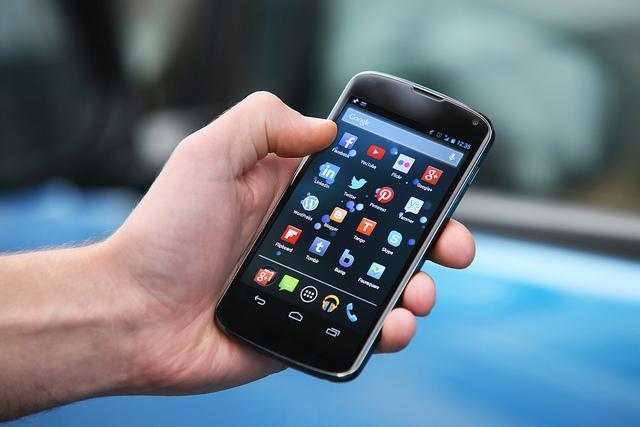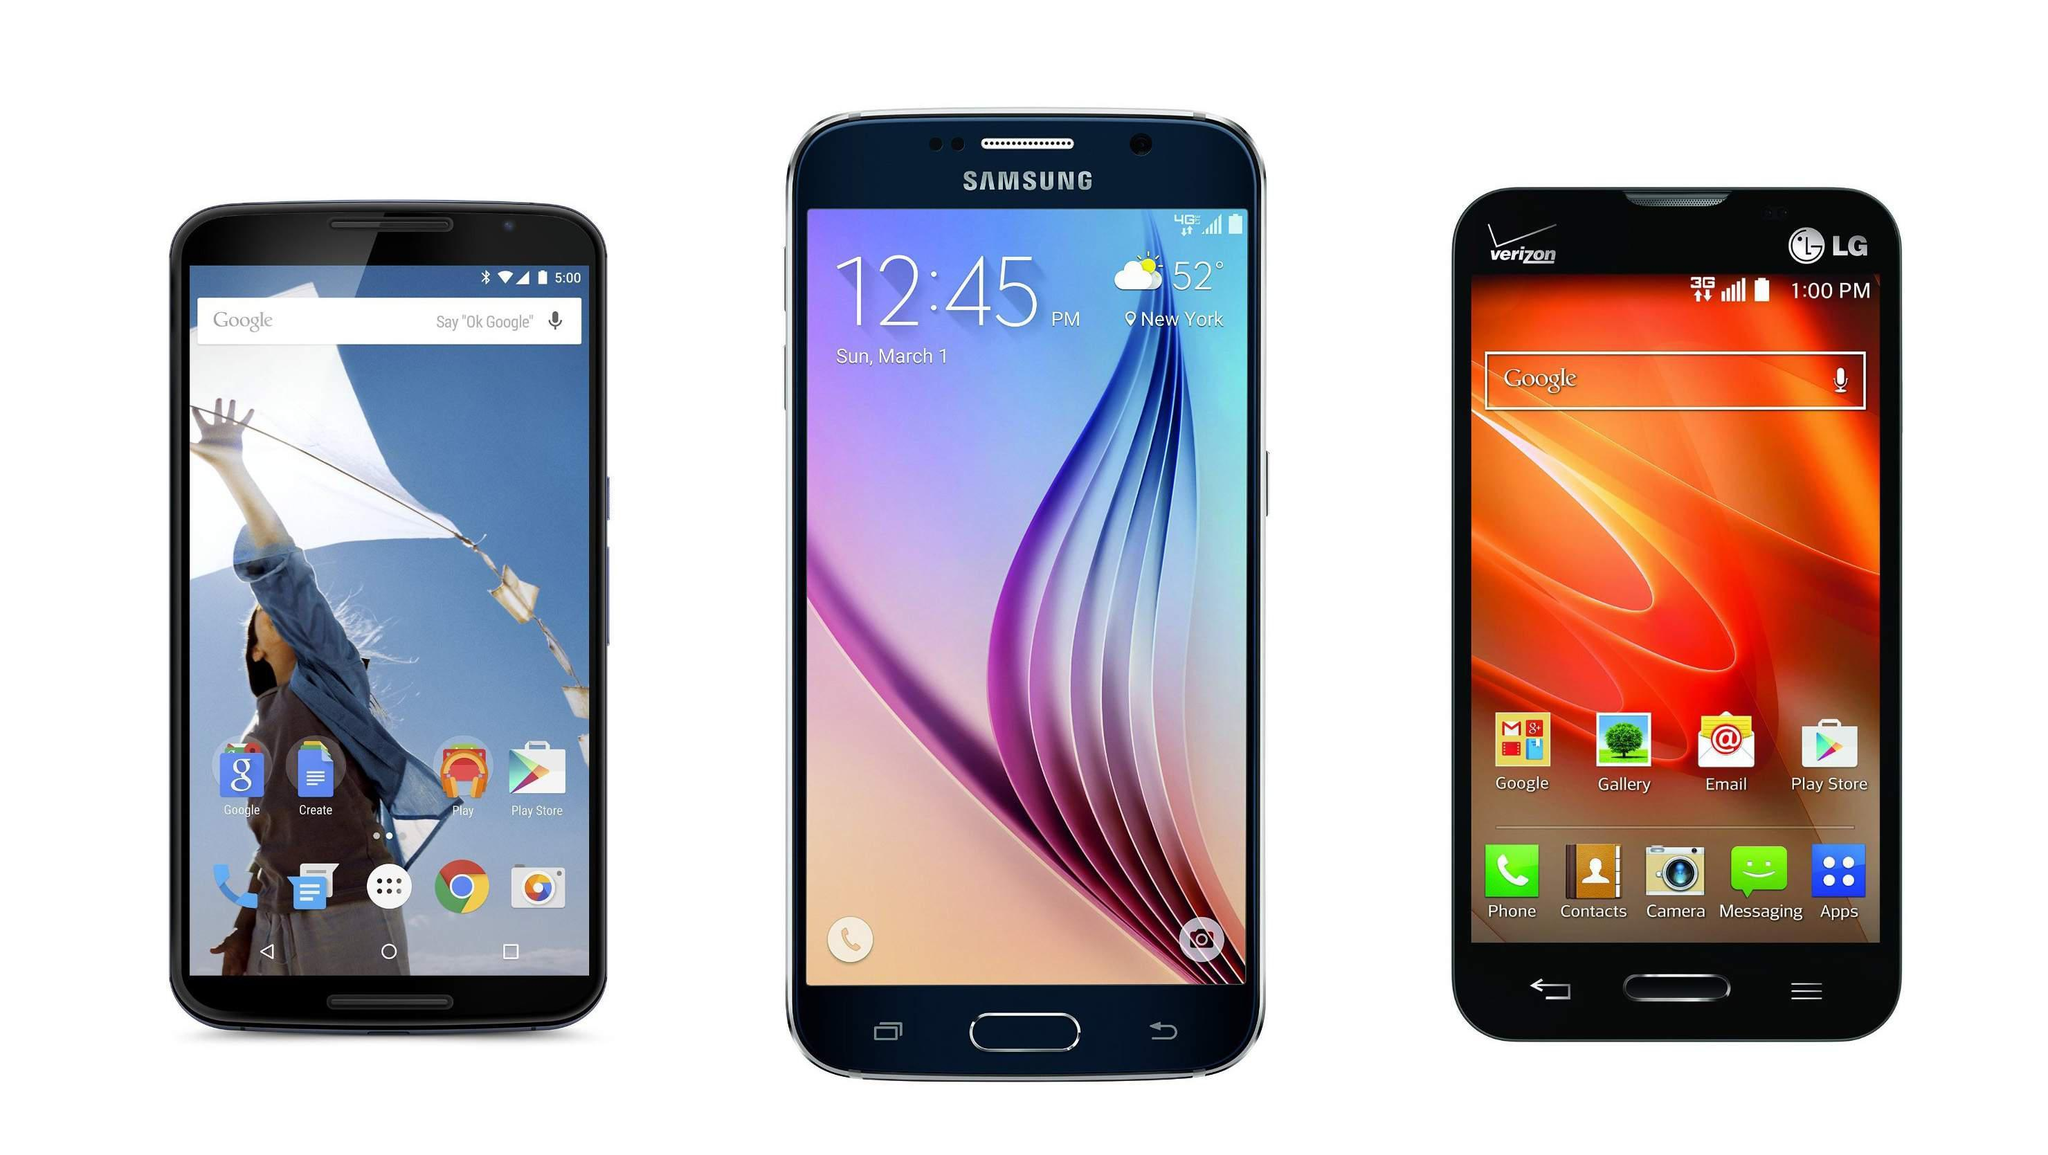The first image is the image on the left, the second image is the image on the right. Evaluate the accuracy of this statement regarding the images: "The right image contains no more than four smart phones.". Is it true? Answer yes or no. Yes. 